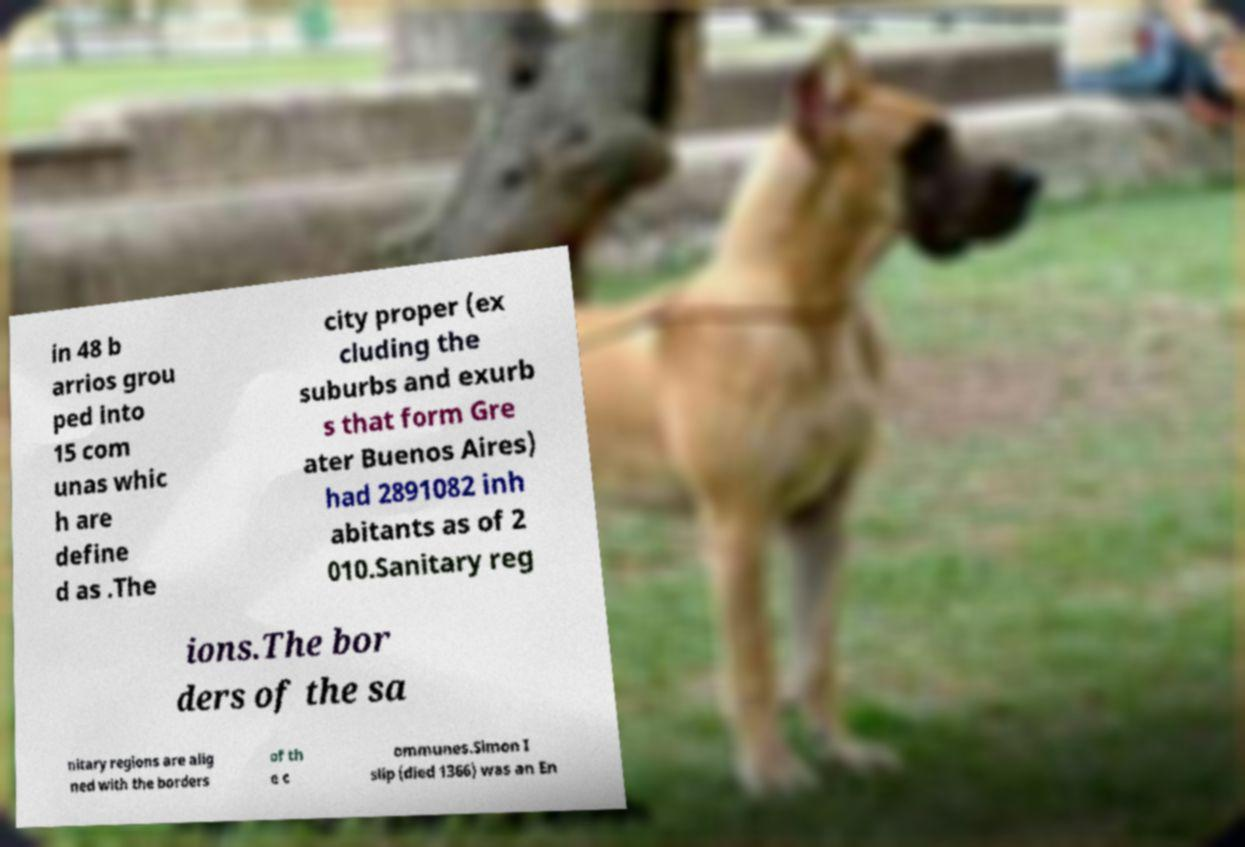I need the written content from this picture converted into text. Can you do that? in 48 b arrios grou ped into 15 com unas whic h are define d as .The city proper (ex cluding the suburbs and exurb s that form Gre ater Buenos Aires) had 2891082 inh abitants as of 2 010.Sanitary reg ions.The bor ders of the sa nitary regions are alig ned with the borders of th e c ommunes.Simon I slip (died 1366) was an En 